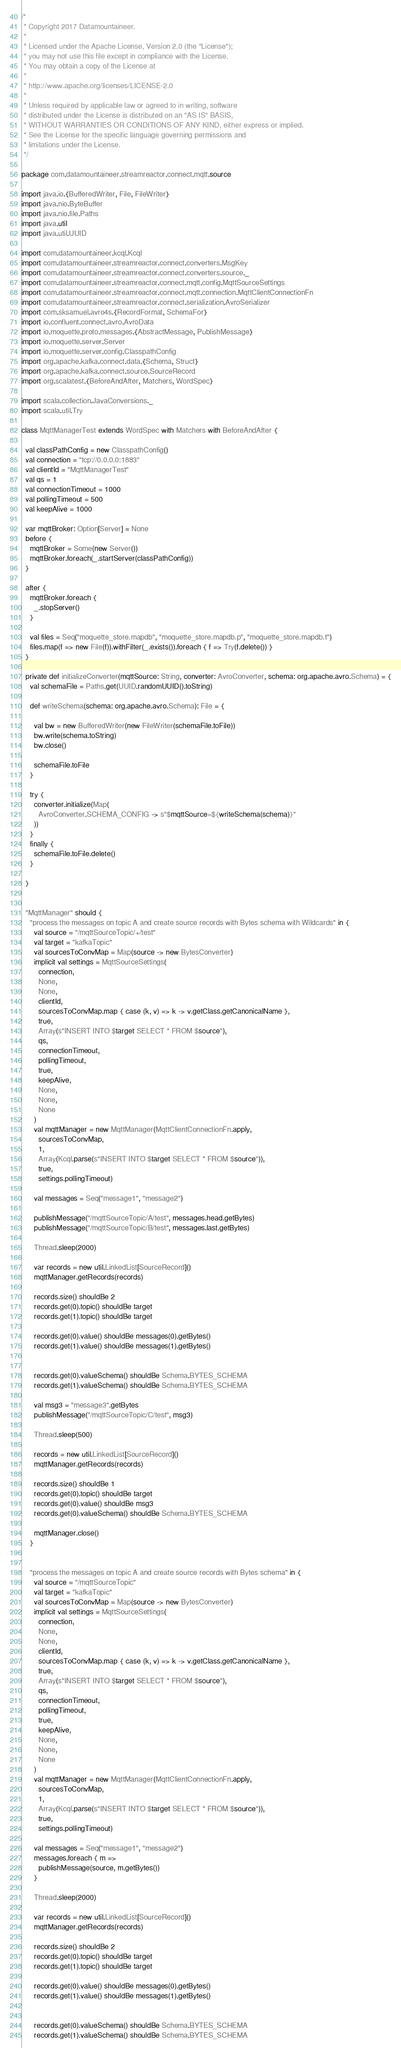<code> <loc_0><loc_0><loc_500><loc_500><_Scala_>/*
 * Copyright 2017 Datamountaineer.
 *
 * Licensed under the Apache License, Version 2.0 (the "License");
 * you may not use this file except in compliance with the License.
 * You may obtain a copy of the License at
 *
 * http://www.apache.org/licenses/LICENSE-2.0
 *
 * Unless required by applicable law or agreed to in writing, software
 * distributed under the License is distributed on an "AS IS" BASIS,
 * WITHOUT WARRANTIES OR CONDITIONS OF ANY KIND, either express or implied.
 * See the License for the specific language governing permissions and
 * limitations under the License.
 */

package com.datamountaineer.streamreactor.connect.mqtt.source

import java.io.{BufferedWriter, File, FileWriter}
import java.nio.ByteBuffer
import java.nio.file.Paths
import java.util
import java.util.UUID

import com.datamountaineer.kcql.Kcql
import com.datamountaineer.streamreactor.connect.converters.MsgKey
import com.datamountaineer.streamreactor.connect.converters.source._
import com.datamountaineer.streamreactor.connect.mqtt.config.MqttSourceSettings
import com.datamountaineer.streamreactor.connect.mqtt.connection.MqttClientConnectionFn
import com.datamountaineer.streamreactor.connect.serialization.AvroSerializer
import com.sksamuel.avro4s.{RecordFormat, SchemaFor}
import io.confluent.connect.avro.AvroData
import io.moquette.proto.messages.{AbstractMessage, PublishMessage}
import io.moquette.server.Server
import io.moquette.server.config.ClasspathConfig
import org.apache.kafka.connect.data.{Schema, Struct}
import org.apache.kafka.connect.source.SourceRecord
import org.scalatest.{BeforeAndAfter, Matchers, WordSpec}

import scala.collection.JavaConversions._
import scala.util.Try

class MqttManagerTest extends WordSpec with Matchers with BeforeAndAfter {

  val classPathConfig = new ClasspathConfig()
  val connection = "tcp://0.0.0.0:1883"
  val clientId = "MqttManagerTest"
  val qs = 1
  val connectionTimeout = 1000
  val pollingTimeout = 500
  val keepAlive = 1000

  var mqttBroker: Option[Server] = None
  before {
    mqttBroker = Some(new Server())
    mqttBroker.foreach(_.startServer(classPathConfig))
  }

  after {
    mqttBroker.foreach {
      _.stopServer()
    }

    val files = Seq("moquette_store.mapdb", "moquette_store.mapdb.p", "moquette_store.mapdb.t")
    files.map(f => new File(f)).withFilter(_.exists()).foreach { f => Try(f.delete()) }
  }

  private def initializeConverter(mqttSource: String, converter: AvroConverter, schema: org.apache.avro.Schema) = {
    val schemaFile = Paths.get(UUID.randomUUID().toString)

    def writeSchema(schema: org.apache.avro.Schema): File = {

      val bw = new BufferedWriter(new FileWriter(schemaFile.toFile))
      bw.write(schema.toString)
      bw.close()

      schemaFile.toFile
    }

    try {
      converter.initialize(Map(
        AvroConverter.SCHEMA_CONFIG -> s"$mqttSource=${writeSchema(schema)}"
      ))
    }
    finally {
      schemaFile.toFile.delete()
    }

  }


  "MqttManager" should {
    "process the messages on topic A and create source records with Bytes schema with Wildcards" in {
      val source = "/mqttSourceTopic/+/test"
      val target = "kafkaTopic"
      val sourcesToConvMap = Map(source -> new BytesConverter)
      implicit val settings = MqttSourceSettings(
        connection,
        None,
        None,
        clientId,
        sourcesToConvMap.map { case (k, v) => k -> v.getClass.getCanonicalName },
        true,
        Array(s"INSERT INTO $target SELECT * FROM $source"),
        qs,
        connectionTimeout,
        pollingTimeout,
        true,
        keepAlive,
        None,
        None,
        None
      )
      val mqttManager = new MqttManager(MqttClientConnectionFn.apply,
        sourcesToConvMap,
        1,
        Array(Kcql.parse(s"INSERT INTO $target SELECT * FROM $source")),
        true,
        settings.pollingTimeout)

      val messages = Seq("message1", "message2")

      publishMessage("/mqttSourceTopic/A/test", messages.head.getBytes)
      publishMessage("/mqttSourceTopic/B/test", messages.last.getBytes)

      Thread.sleep(2000)

      var records = new util.LinkedList[SourceRecord]()
      mqttManager.getRecords(records)

      records.size() shouldBe 2
      records.get(0).topic() shouldBe target
      records.get(1).topic() shouldBe target

      records.get(0).value() shouldBe messages(0).getBytes()
      records.get(1).value() shouldBe messages(1).getBytes()


      records.get(0).valueSchema() shouldBe Schema.BYTES_SCHEMA
      records.get(1).valueSchema() shouldBe Schema.BYTES_SCHEMA

      val msg3 = "message3".getBytes
      publishMessage("/mqttSourceTopic/C/test", msg3)

      Thread.sleep(500)

      records = new util.LinkedList[SourceRecord]()
      mqttManager.getRecords(records)

      records.size() shouldBe 1
      records.get(0).topic() shouldBe target
      records.get(0).value() shouldBe msg3
      records.get(0).valueSchema() shouldBe Schema.BYTES_SCHEMA

      mqttManager.close()
    }


    "process the messages on topic A and create source records with Bytes schema" in {
      val source = "/mqttSourceTopic"
      val target = "kafkaTopic"
      val sourcesToConvMap = Map(source -> new BytesConverter)
      implicit val settings = MqttSourceSettings(
        connection,
        None,
        None,
        clientId,
        sourcesToConvMap.map { case (k, v) => k -> v.getClass.getCanonicalName },
        true,
        Array(s"INSERT INTO $target SELECT * FROM $source"),
        qs,
        connectionTimeout,
        pollingTimeout,
        true,
        keepAlive,
        None,
        None,
        None
      )
      val mqttManager = new MqttManager(MqttClientConnectionFn.apply,
        sourcesToConvMap,
        1,
        Array(Kcql.parse(s"INSERT INTO $target SELECT * FROM $source")),
        true,
        settings.pollingTimeout)

      val messages = Seq("message1", "message2")
      messages.foreach { m =>
        publishMessage(source, m.getBytes())
      }

      Thread.sleep(2000)

      var records = new util.LinkedList[SourceRecord]()
      mqttManager.getRecords(records)

      records.size() shouldBe 2
      records.get(0).topic() shouldBe target
      records.get(1).topic() shouldBe target

      records.get(0).value() shouldBe messages(0).getBytes()
      records.get(1).value() shouldBe messages(1).getBytes()


      records.get(0).valueSchema() shouldBe Schema.BYTES_SCHEMA
      records.get(1).valueSchema() shouldBe Schema.BYTES_SCHEMA
</code> 